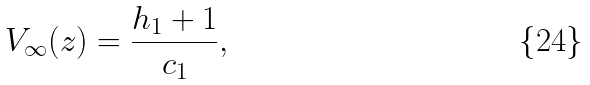<formula> <loc_0><loc_0><loc_500><loc_500>V _ { \infty } ( z ) = \frac { h _ { 1 } + 1 } { c _ { 1 } } ,</formula> 